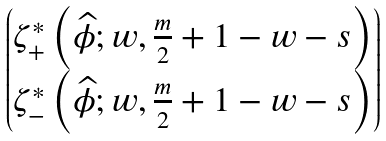<formula> <loc_0><loc_0><loc_500><loc_500>\begin{pmatrix} \zeta ^ { * } _ { + } \left ( \widehat { \phi } ; w , \frac { m } { 2 } + 1 - w - s \right ) \\ \zeta ^ { * } _ { - } \left ( \widehat { \phi } ; w , \frac { m } { 2 } + 1 - w - s \right ) \end{pmatrix}</formula> 